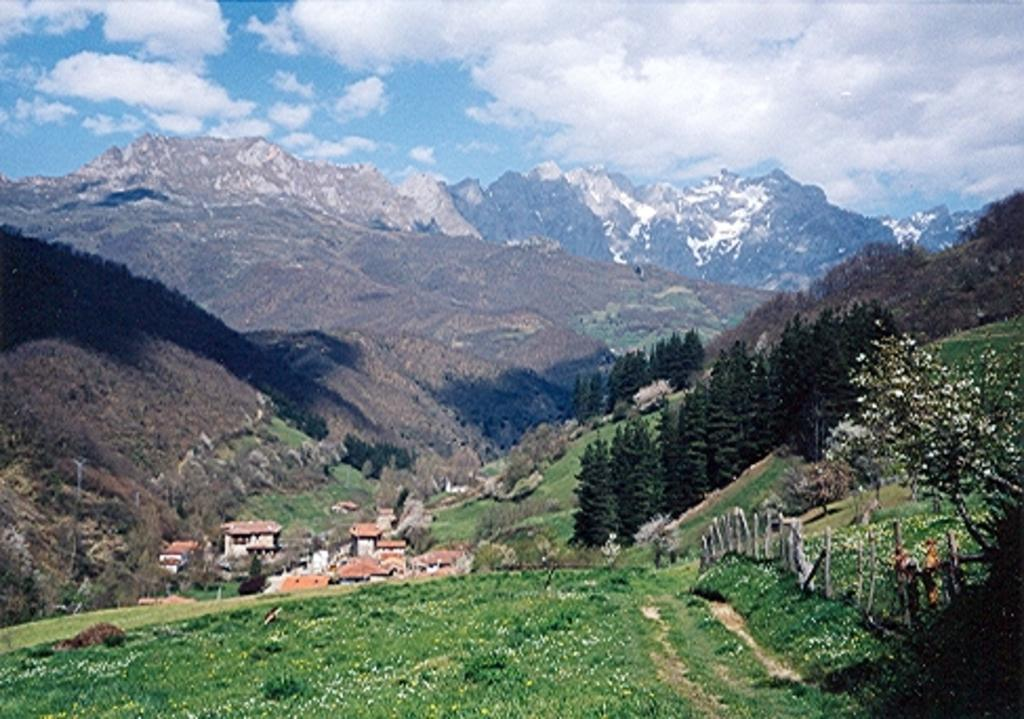What type of vegetation is present in the image? There is grass in the image. What structures can be seen in the image? There are poles, buildings, and trees in the image. What type of natural landform is visible in the image? There are mountains in the image. What is visible in the background of the image? The sky is visible in the background of the image. What can be seen in the sky in the image? Clouds are present in the sky. What is the purpose of the earth in the image? There is no specific reference to "earth" in the image, and therefore it is not possible to determine its purpose. Can you see any cables connecting the poles in the image? There is no mention of cables connecting the poles in the provided facts, so it cannot be determined from the image. 